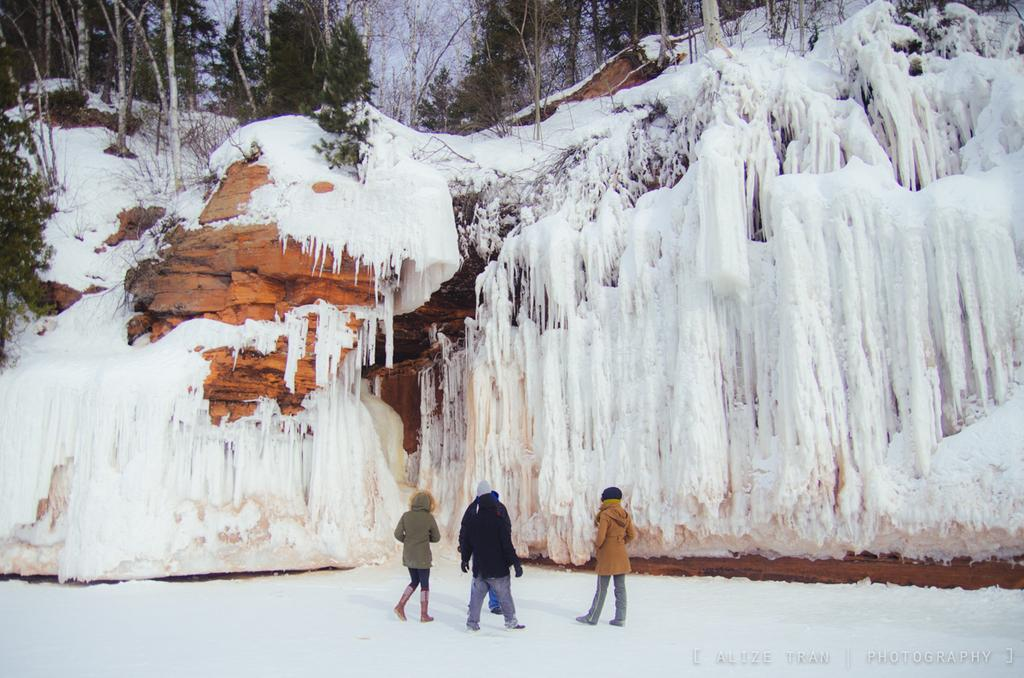How many people are in the image? There is a group of people in the image, but the exact number cannot be determined from the provided facts. What is the surface the people are standing on? The people are standing on snow in the image. What can be seen in the background of the image? There are mountains and a group of trees in the background of the image. What type of pizzas are being served to the people in the image? There is no mention of pizzas or food in the image; the people are standing on snow with mountains and trees in the background. 